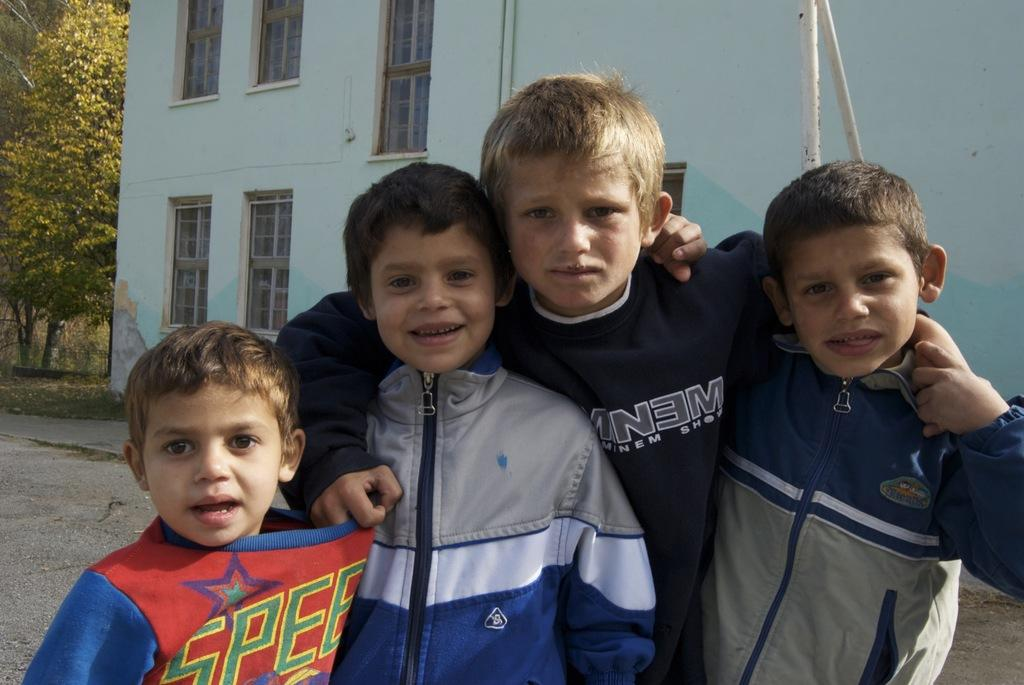<image>
Give a short and clear explanation of the subsequent image. The tallest of the 4 boys has on a shirt that says something "NEM" but is obscured by another boy. 